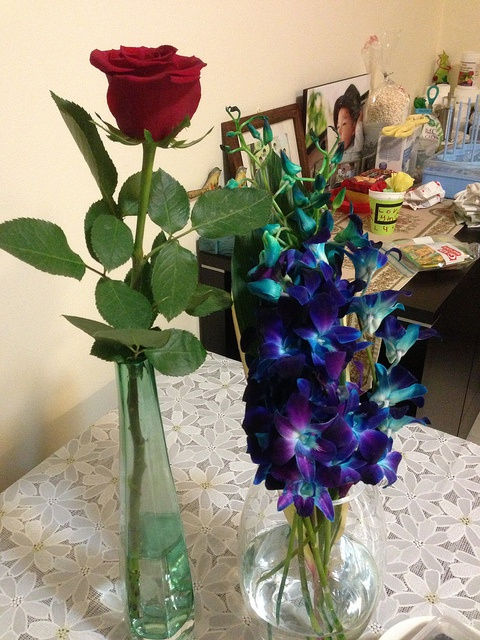Describe the objects in this image and their specific colors. I can see dining table in beige, lightgray, darkgray, and gray tones, potted plant in beige, black, navy, darkgray, and lightgray tones, potted plant in beige, darkgreen, and maroon tones, vase in beige, lightgray, darkgray, and gray tones, and vase in beige, darkgreen, gray, and darkgray tones in this image. 